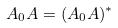<formula> <loc_0><loc_0><loc_500><loc_500>A _ { 0 } A = ( A _ { 0 } A ) ^ { * }</formula> 